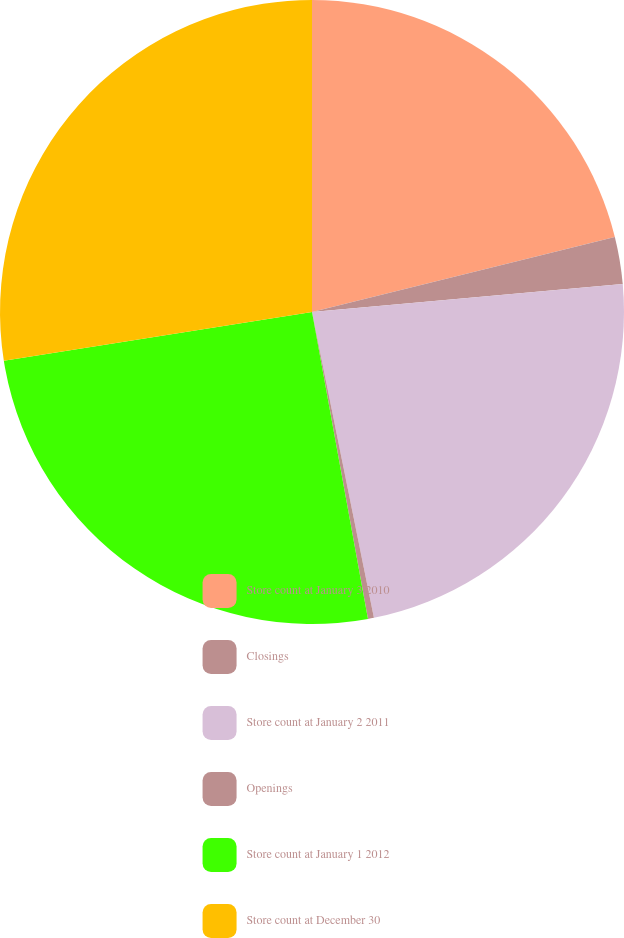<chart> <loc_0><loc_0><loc_500><loc_500><pie_chart><fcel>Store count at January 3 2010<fcel>Closings<fcel>Store count at January 2 2011<fcel>Openings<fcel>Store count at January 1 2012<fcel>Store count at December 30<nl><fcel>21.13%<fcel>2.43%<fcel>23.25%<fcel>0.31%<fcel>25.37%<fcel>27.49%<nl></chart> 